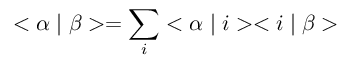Convert formula to latex. <formula><loc_0><loc_0><loc_500><loc_500>< \alpha | \beta > = \sum _ { i } < \alpha | i > < i | \beta ></formula> 